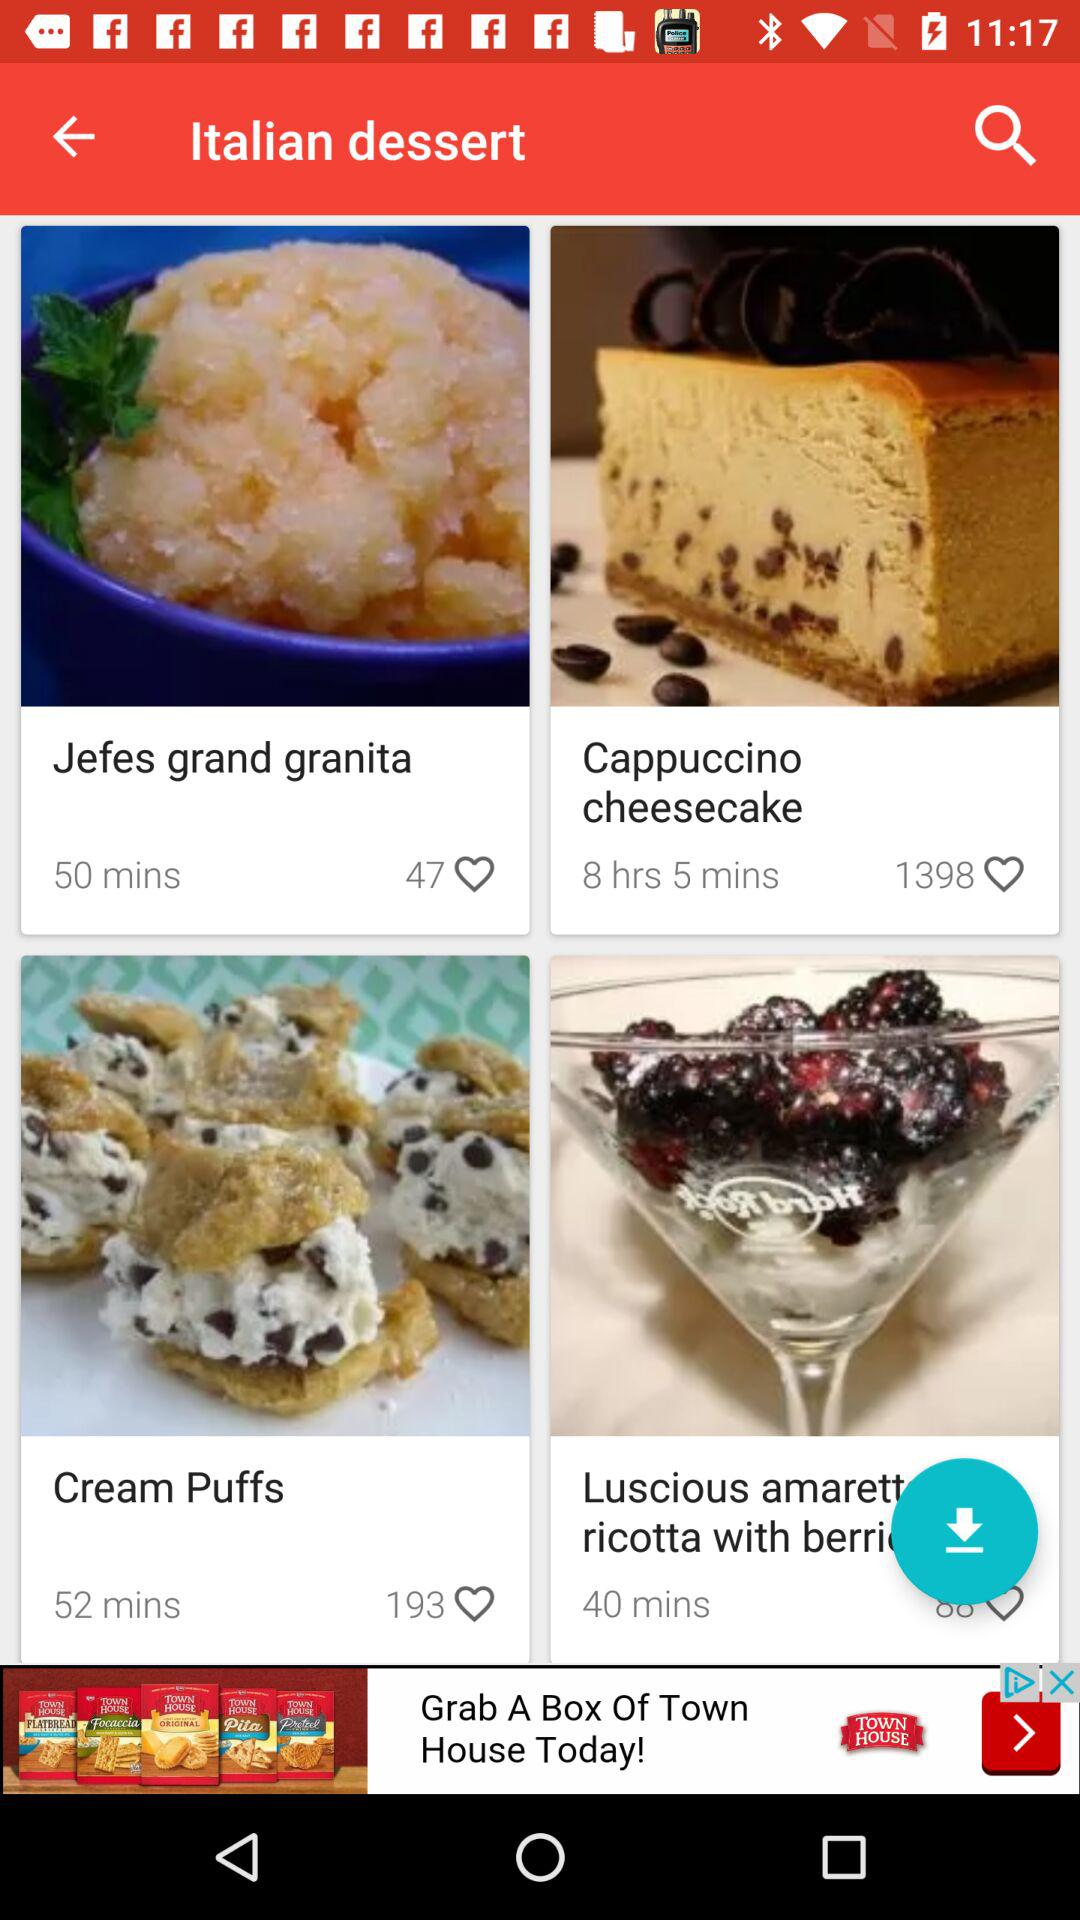What's the selected menu option? The selected option is "Home". 